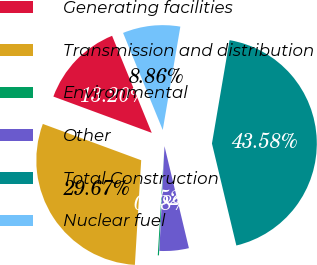Convert chart. <chart><loc_0><loc_0><loc_500><loc_500><pie_chart><fcel>Generating facilities<fcel>Transmission and distribution<fcel>Environmental<fcel>Other<fcel>Total Construction<fcel>Nuclear fuel<nl><fcel>13.2%<fcel>29.67%<fcel>0.18%<fcel>4.52%<fcel>43.58%<fcel>8.86%<nl></chart> 